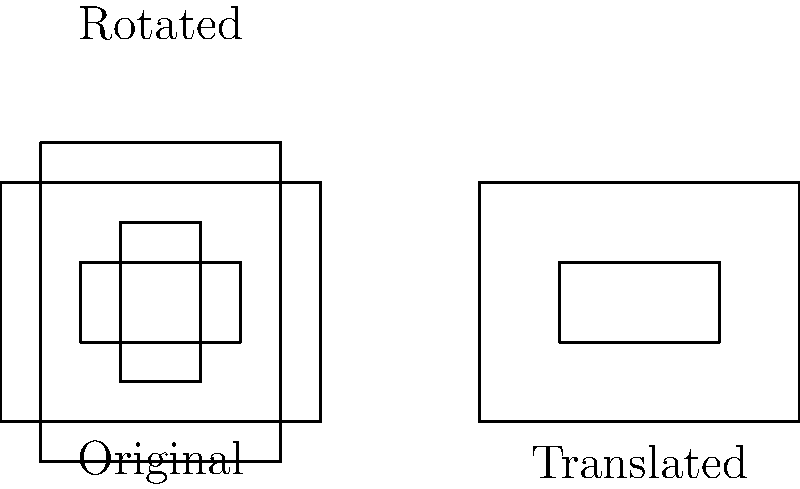In the context of crime fiction movie posters, consider the transformations applied to the rectangular frames representing different poster layouts. If a translation of 6 units to the right is followed by a 90-degree clockwise rotation around the center point (2, 1.5) of the original frame, what single transformation could replace this composition to achieve the same result? To solve this problem, let's follow these steps:

1. Analyze the given transformations:
   a. Translation: 6 units to the right
   b. Rotation: 90 degrees clockwise around (2, 1.5)

2. Consider the properties of composition of transformations:
   - The order of transformations matters
   - A composition of a translation and a rotation can be replaced by a single rotation around a different center

3. Determine the new center of rotation:
   - The center of rotation after translation would be (8, 1.5)
   - This is because (2, 1.5) + (6, 0) = (8, 1.5)

4. Verify that a 90-degree clockwise rotation around (8, 1.5) produces the same result:
   - The original rectangle corners would transform to the same positions as in the given sequence of transformations

5. Formulate the answer:
   The composition can be replaced by a single 90-degree clockwise rotation around the point (8, 1.5)

This transformation preserves the relative positions and orientations of the poster layouts while achieving the same final configuration, demonstrating how different sequences of transformations can result in equivalent outcomes in poster design.
Answer: 90-degree clockwise rotation around (8, 1.5) 